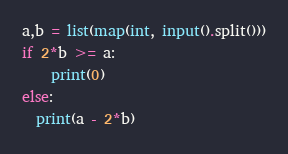Convert code to text. <code><loc_0><loc_0><loc_500><loc_500><_Python_>a,b = list(map(int, input().split()))
if 2*b >= a:
	print(0)
else:
  print(a - 2*b)</code> 